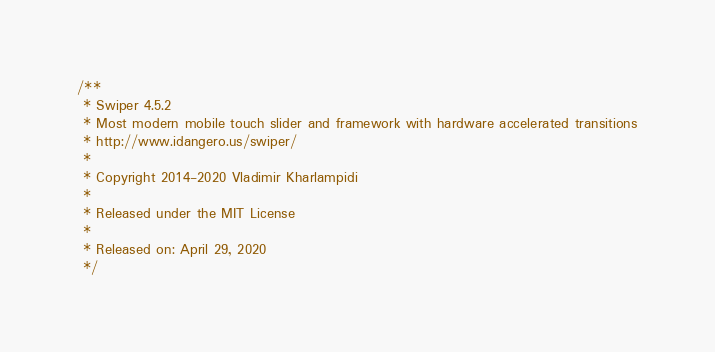Convert code to text. <code><loc_0><loc_0><loc_500><loc_500><_CSS_>/**
 * Swiper 4.5.2
 * Most modern mobile touch slider and framework with hardware accelerated transitions
 * http://www.idangero.us/swiper/
 *
 * Copyright 2014-2020 Vladimir Kharlampidi
 *
 * Released under the MIT License
 *
 * Released on: April 29, 2020
 */</code> 